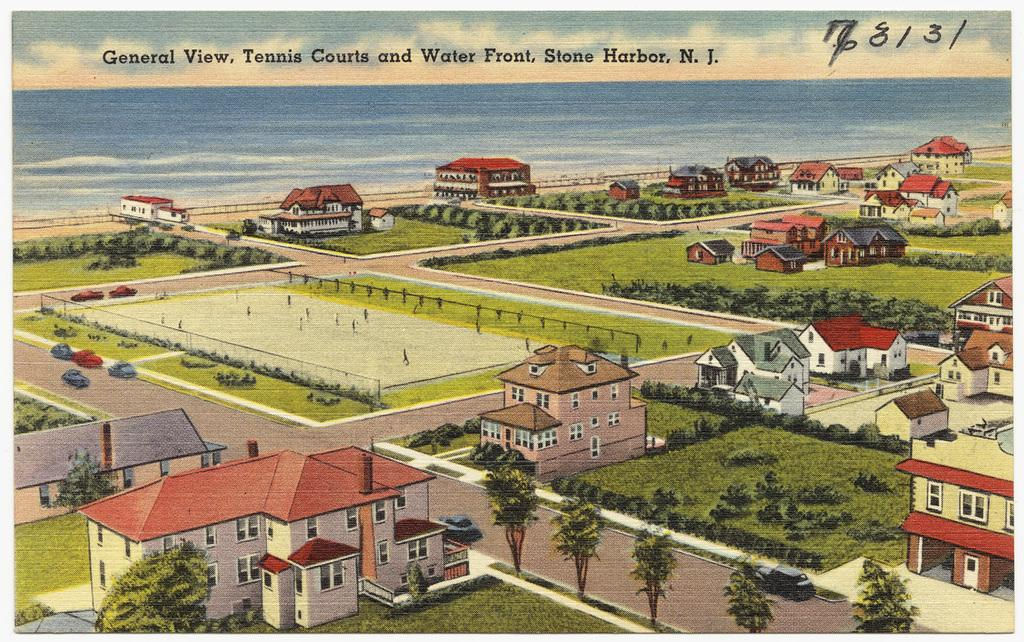What type of structures can be seen in the image? There are houses in the image. What type of vegetation is present in the image? There are trees and grass in the image. What natural feature can be seen in the background of the image? The background of the image includes water. What is visible in the sky in the image? The sky is visible in the background of the image, and clouds are present. What additional information is provided at the top of the image? There is text and a number at the top of the image. What type of voice can be heard coming from the houses in the image? There is no voice present in the image; it is a still image with no audio. What type of thread is used to connect the trees in the image? There is no thread connecting the trees in the image; they are separate entities. 